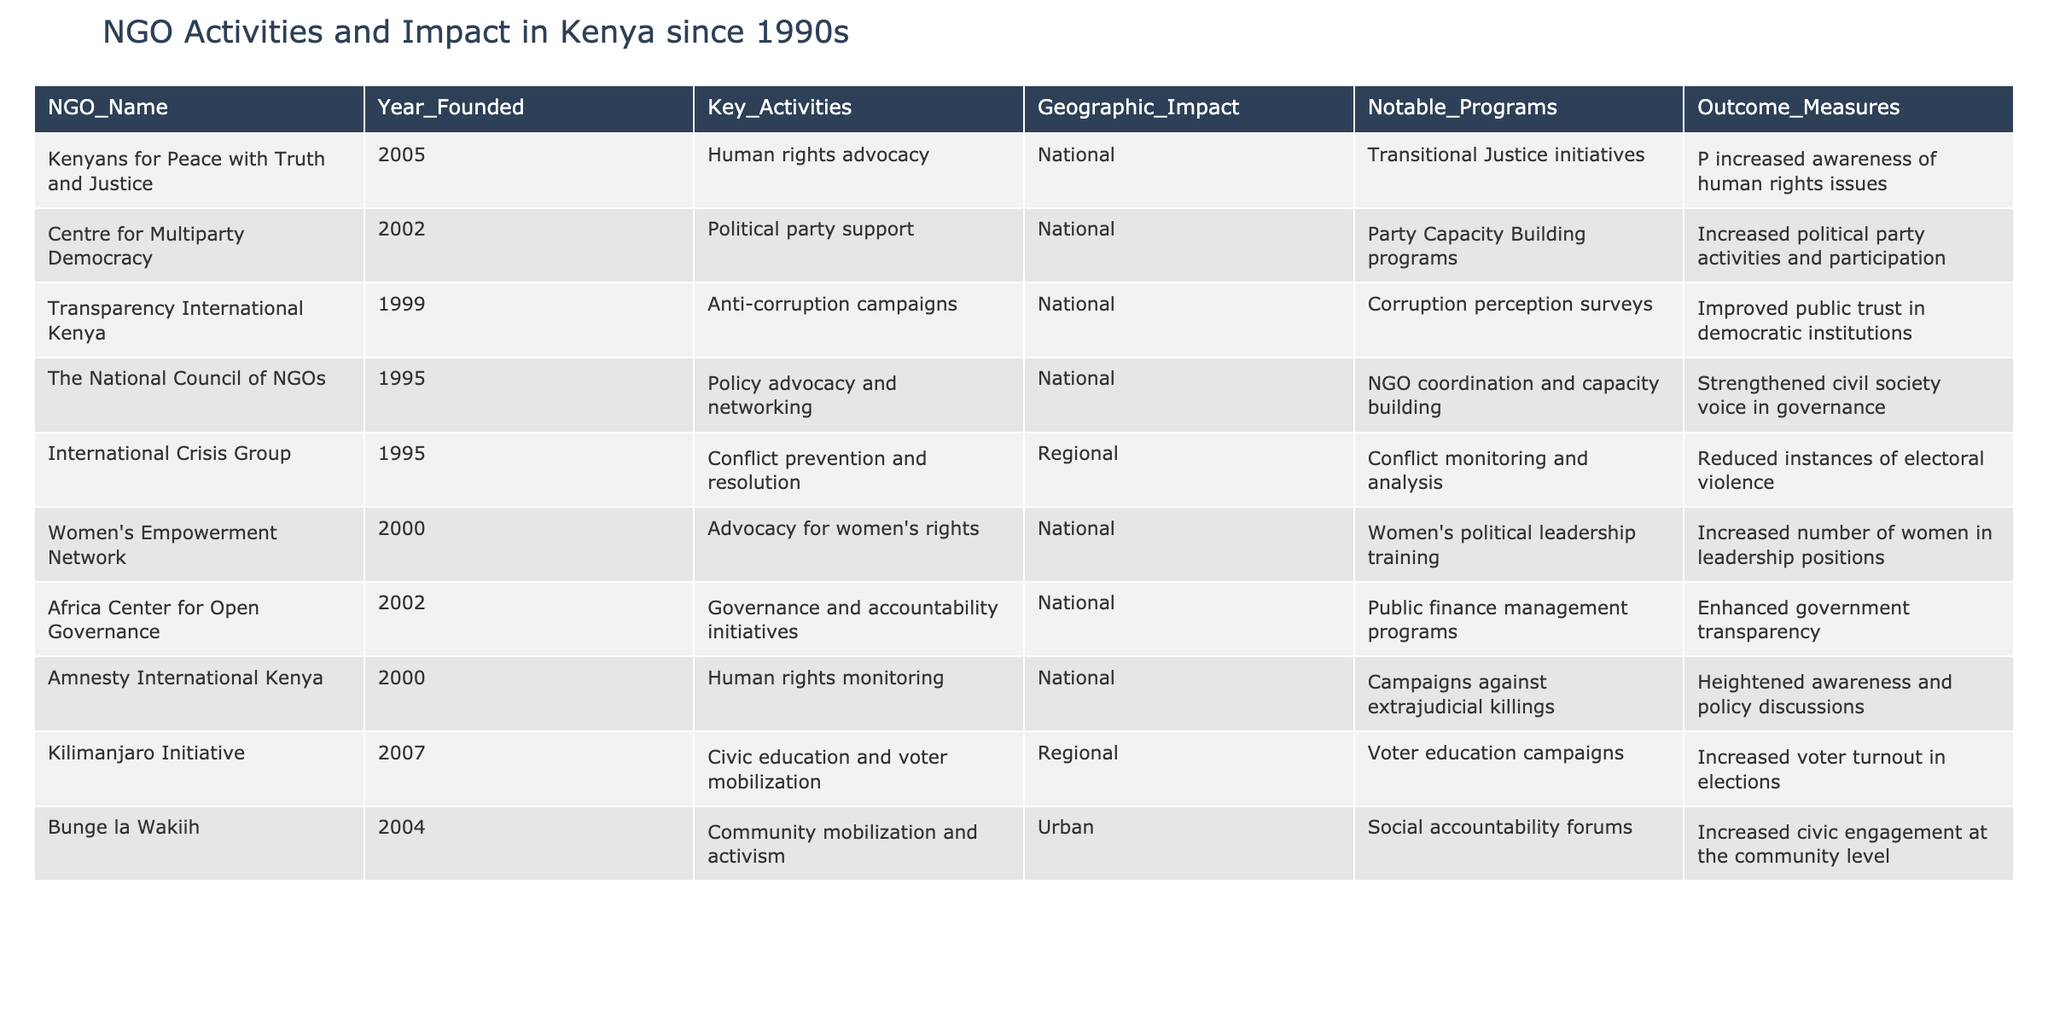What is the founding year of the NGO called "Kenyans for Peace with Truth and Justice"? The table lists the NGO names along with their respective founding years. By locating "Kenyans for Peace with Truth and Justice" in the NGO_Name column, I can find that its Year_Founded is 2005.
Answer: 2005 Which NGO focuses on women's rights and when was it founded? By scanning the table for key activities that mention women's rights, I identify "Women's Empowerment Network" as the relevant NGO. The Year_Founded for this NGO is listed as 2000.
Answer: Women's Empowerment Network, 2000 How many NGOs were founded in the 1990s? I review the Year_Founded column and count the NGOs founded between 1990 and 1999. The findings indicate that there are four NGOs established in the 1990s: "The National Council of NGOs" (1995), "International Crisis Group" (1995), and "Transparency International Kenya" (1999).
Answer: 4 Which NGO had the outcome measure of "Increased political party activities and participation"? I look in the Outcome_Measures column and find the relevant entry that corresponds to increased political party activities. It is associated with the NGO "Centre for Multiparty Democracy."
Answer: Centre for Multiparty Democracy Which program was notable for the "Kilimanjaro Initiative" and what was its impact? According to the Notable_Programs column for "Kilimanjaro Initiative," its key program is "Voter education campaigns." The Outcome_Measures column indicates that its impact was "Increased voter turnout in elections."
Answer: Voter education campaigns; Increased voter turnout in elections What is the main activity of the "Africa Center for Open Governance"? I focus on the Key_Activities column and see that the main activity for the Africa Center for Open Governance is "Governance and accountability initiatives."
Answer: Governance and accountability initiatives Did "Amnesty International Kenya" focus on anti-corruption campaigns? I verify the Key_Activities for "Amnesty International Kenya," which are noted as "Human rights monitoring." Thus, it did not focus on anti-corruption campaigns; that is the focus of Transparency International Kenya instead. Therefore, the answer is no.
Answer: No Which NGO had programs related to transitional justice, and what was one outcome? By reviewing the Notable_Programs column, I find that "Kenyans for Peace with Truth and Justice" focuses on "Transitional Justice initiatives." The corresponding Outcome_Measures state that the outcome was "Increased awareness of human rights issues."
Answer: Kenyans for Peace with Truth and Justice; Increased awareness of human rights issues What is the difference in founding years between the "Centre for Multiparty Democracy" and "Transparency International Kenya"? The founding year for the Centre for Multiparty Democracy is 2002, and for Transparency International Kenya is 1999. Calculating the difference gives 2002 - 1999 = 3 years.
Answer: 3 years 